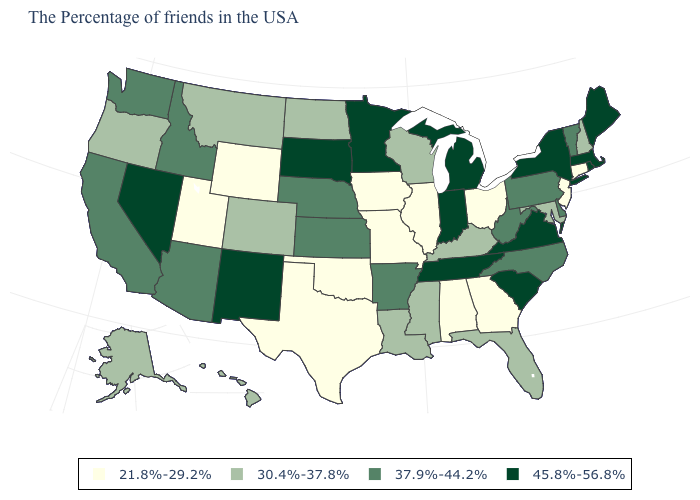What is the value of Tennessee?
Write a very short answer. 45.8%-56.8%. What is the value of Nebraska?
Be succinct. 37.9%-44.2%. Is the legend a continuous bar?
Keep it brief. No. Does Colorado have the same value as Florida?
Short answer required. Yes. Does Virginia have the lowest value in the South?
Concise answer only. No. Among the states that border Idaho , which have the lowest value?
Be succinct. Wyoming, Utah. Name the states that have a value in the range 21.8%-29.2%?
Short answer required. Connecticut, New Jersey, Ohio, Georgia, Alabama, Illinois, Missouri, Iowa, Oklahoma, Texas, Wyoming, Utah. Among the states that border Virginia , which have the highest value?
Quick response, please. Tennessee. What is the value of Georgia?
Keep it brief. 21.8%-29.2%. Among the states that border Ohio , does Indiana have the highest value?
Concise answer only. Yes. Among the states that border Nebraska , which have the lowest value?
Write a very short answer. Missouri, Iowa, Wyoming. Name the states that have a value in the range 30.4%-37.8%?
Concise answer only. New Hampshire, Maryland, Florida, Kentucky, Wisconsin, Mississippi, Louisiana, North Dakota, Colorado, Montana, Oregon, Alaska, Hawaii. Does Massachusetts have a higher value than New York?
Short answer required. No. Which states have the lowest value in the Northeast?
Write a very short answer. Connecticut, New Jersey. What is the value of Missouri?
Concise answer only. 21.8%-29.2%. 